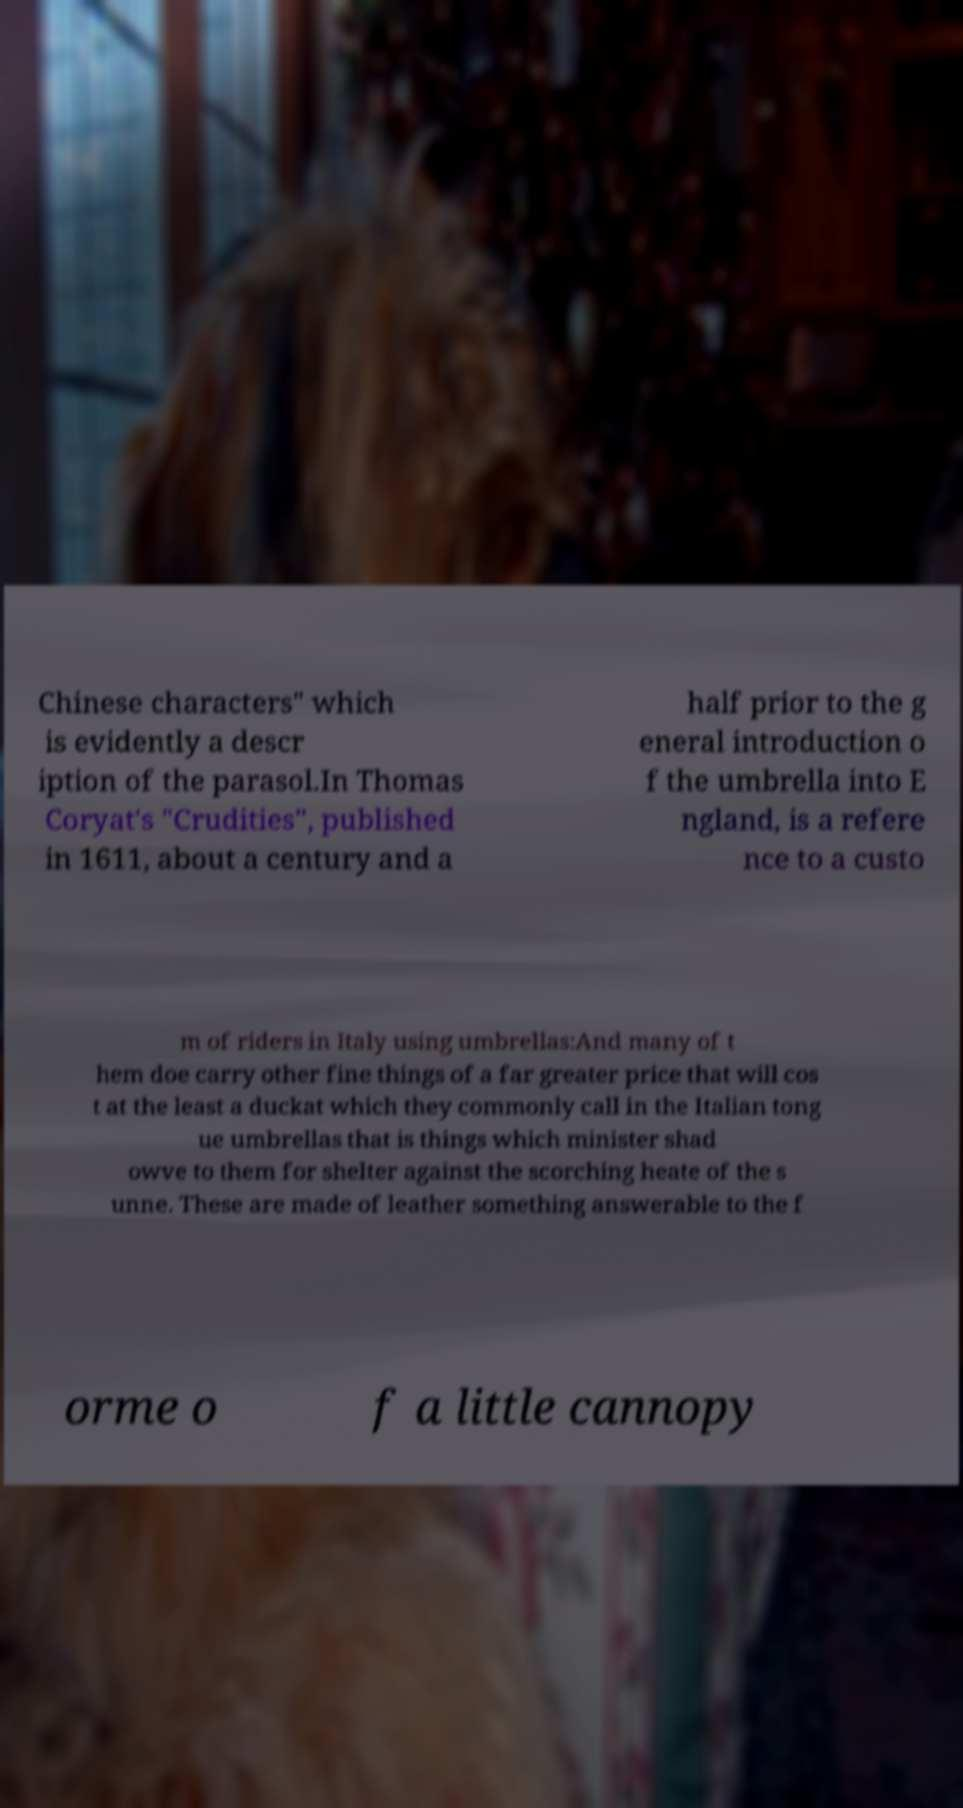There's text embedded in this image that I need extracted. Can you transcribe it verbatim? Chinese characters" which is evidently a descr iption of the parasol.In Thomas Coryat's "Crudities", published in 1611, about a century and a half prior to the g eneral introduction o f the umbrella into E ngland, is a refere nce to a custo m of riders in Italy using umbrellas:And many of t hem doe carry other fine things of a far greater price that will cos t at the least a duckat which they commonly call in the Italian tong ue umbrellas that is things which minister shad owve to them for shelter against the scorching heate of the s unne. These are made of leather something answerable to the f orme o f a little cannopy 